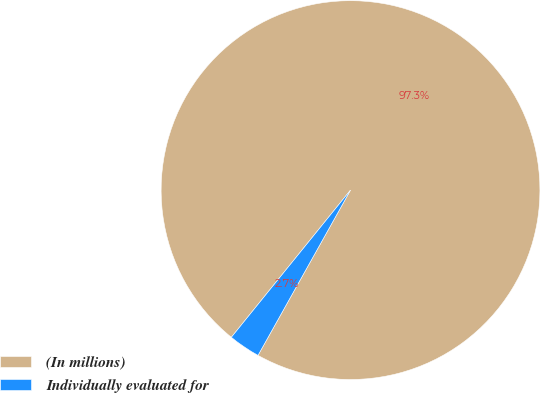Convert chart to OTSL. <chart><loc_0><loc_0><loc_500><loc_500><pie_chart><fcel>(In millions)<fcel>Individually evaluated for<nl><fcel>97.29%<fcel>2.71%<nl></chart> 